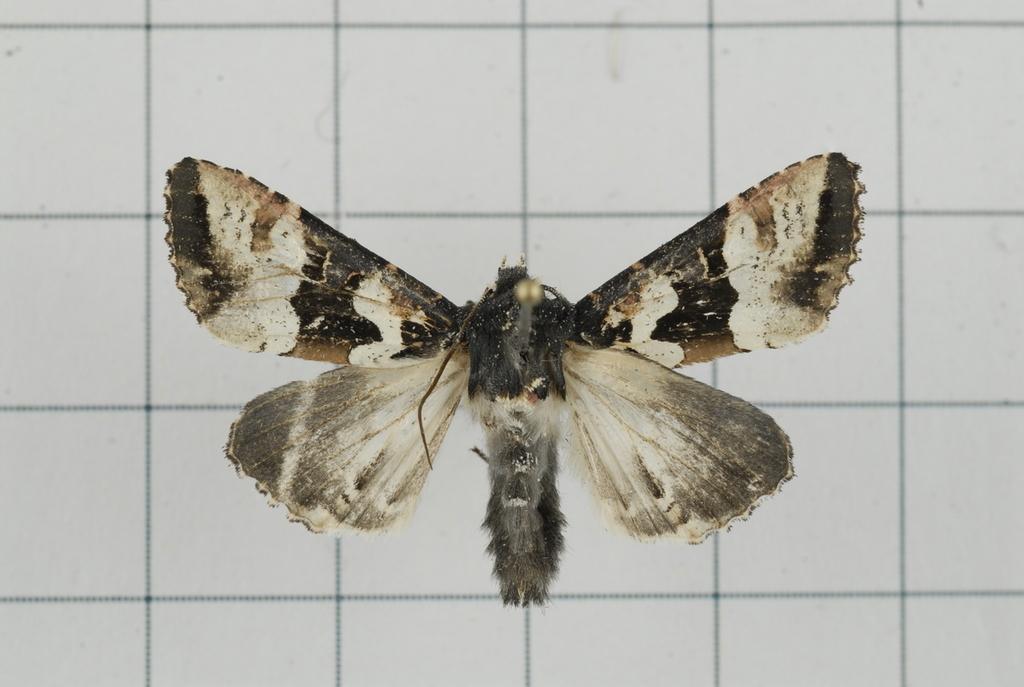Describe this image in one or two sentences. In this image I can see an insect in the foreground, and wall in the background. 